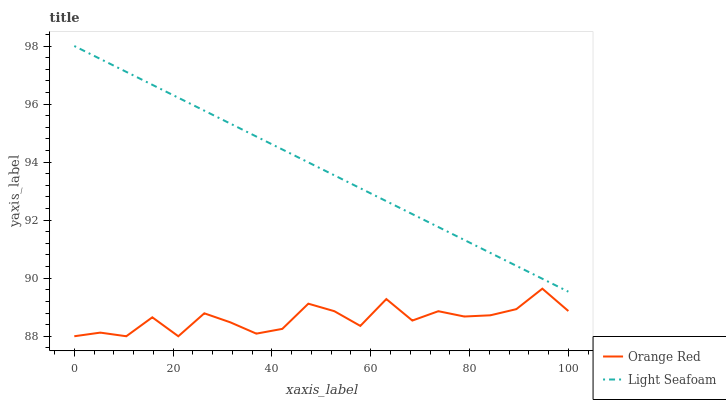Does Orange Red have the minimum area under the curve?
Answer yes or no. Yes. Does Light Seafoam have the maximum area under the curve?
Answer yes or no. Yes. Does Orange Red have the maximum area under the curve?
Answer yes or no. No. Is Light Seafoam the smoothest?
Answer yes or no. Yes. Is Orange Red the roughest?
Answer yes or no. Yes. Is Orange Red the smoothest?
Answer yes or no. No. Does Orange Red have the lowest value?
Answer yes or no. Yes. Does Light Seafoam have the highest value?
Answer yes or no. Yes. Does Orange Red have the highest value?
Answer yes or no. No. Is Orange Red less than Light Seafoam?
Answer yes or no. Yes. Is Light Seafoam greater than Orange Red?
Answer yes or no. Yes. Does Orange Red intersect Light Seafoam?
Answer yes or no. No. 